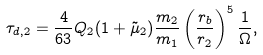<formula> <loc_0><loc_0><loc_500><loc_500>\tau _ { d , 2 } = \frac { 4 } { 6 3 } Q _ { 2 } ( 1 + { \tilde { \mu } _ { 2 } } ) \frac { m _ { 2 } } { m _ { 1 } } \left ( \frac { r _ { b } } { r _ { 2 } } \right ) ^ { 5 } \frac { 1 } { \Omega } ,</formula> 